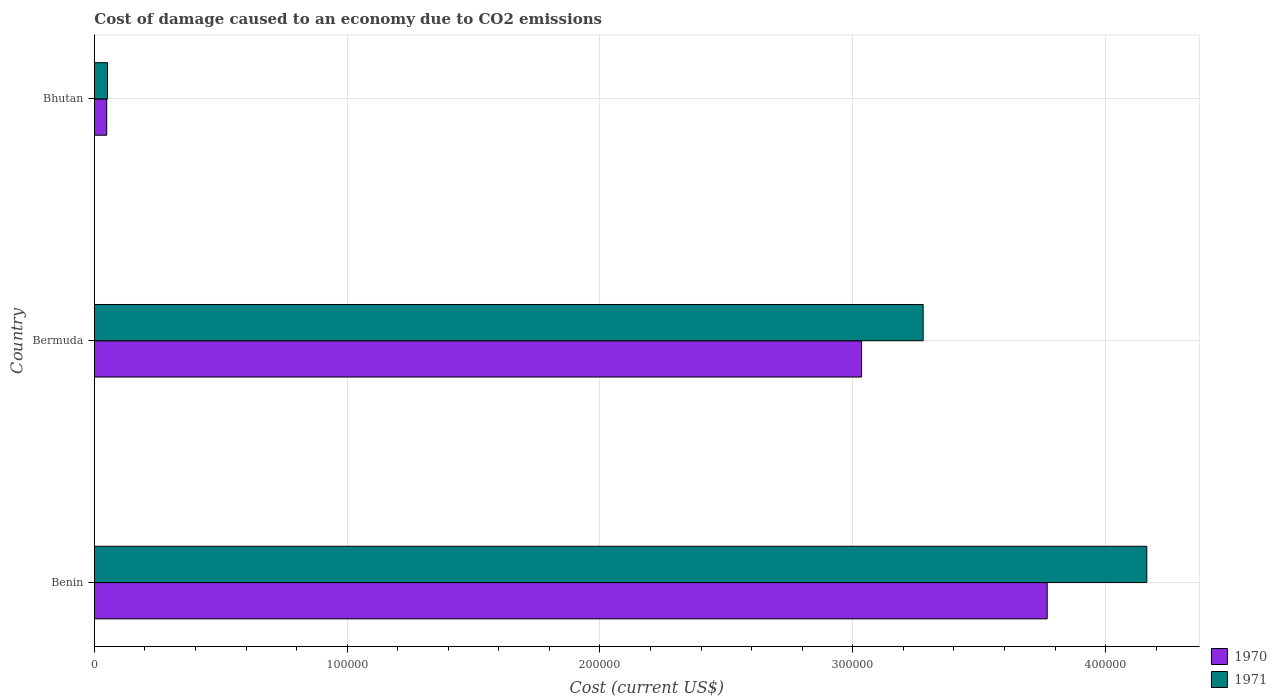How many different coloured bars are there?
Keep it short and to the point. 2. Are the number of bars per tick equal to the number of legend labels?
Provide a succinct answer. Yes. How many bars are there on the 2nd tick from the top?
Your answer should be compact. 2. What is the label of the 2nd group of bars from the top?
Provide a short and direct response. Bermuda. In how many cases, is the number of bars for a given country not equal to the number of legend labels?
Provide a succinct answer. 0. What is the cost of damage caused due to CO2 emissisons in 1971 in Benin?
Your answer should be very brief. 4.16e+05. Across all countries, what is the maximum cost of damage caused due to CO2 emissisons in 1971?
Ensure brevity in your answer.  4.16e+05. Across all countries, what is the minimum cost of damage caused due to CO2 emissisons in 1970?
Provide a short and direct response. 4894.68. In which country was the cost of damage caused due to CO2 emissisons in 1970 maximum?
Offer a terse response. Benin. In which country was the cost of damage caused due to CO2 emissisons in 1970 minimum?
Offer a very short reply. Bhutan. What is the total cost of damage caused due to CO2 emissisons in 1971 in the graph?
Offer a very short reply. 7.49e+05. What is the difference between the cost of damage caused due to CO2 emissisons in 1970 in Benin and that in Bhutan?
Ensure brevity in your answer.  3.72e+05. What is the difference between the cost of damage caused due to CO2 emissisons in 1971 in Bhutan and the cost of damage caused due to CO2 emissisons in 1970 in Benin?
Your answer should be very brief. -3.72e+05. What is the average cost of damage caused due to CO2 emissisons in 1971 per country?
Your answer should be very brief. 2.50e+05. What is the difference between the cost of damage caused due to CO2 emissisons in 1971 and cost of damage caused due to CO2 emissisons in 1970 in Bhutan?
Your answer should be very brief. 308.99. What is the ratio of the cost of damage caused due to CO2 emissisons in 1970 in Bermuda to that in Bhutan?
Make the answer very short. 62. Is the cost of damage caused due to CO2 emissisons in 1971 in Bermuda less than that in Bhutan?
Your answer should be compact. No. Is the difference between the cost of damage caused due to CO2 emissisons in 1971 in Benin and Bermuda greater than the difference between the cost of damage caused due to CO2 emissisons in 1970 in Benin and Bermuda?
Your response must be concise. Yes. What is the difference between the highest and the second highest cost of damage caused due to CO2 emissisons in 1971?
Ensure brevity in your answer.  8.85e+04. What is the difference between the highest and the lowest cost of damage caused due to CO2 emissisons in 1970?
Give a very brief answer. 3.72e+05. What does the 1st bar from the top in Benin represents?
Offer a terse response. 1971. How many bars are there?
Offer a terse response. 6. Are all the bars in the graph horizontal?
Make the answer very short. Yes. Does the graph contain grids?
Make the answer very short. Yes. Where does the legend appear in the graph?
Your response must be concise. Bottom right. How many legend labels are there?
Keep it short and to the point. 2. What is the title of the graph?
Ensure brevity in your answer.  Cost of damage caused to an economy due to CO2 emissions. What is the label or title of the X-axis?
Your answer should be very brief. Cost (current US$). What is the Cost (current US$) in 1970 in Benin?
Your answer should be very brief. 3.77e+05. What is the Cost (current US$) in 1971 in Benin?
Make the answer very short. 4.16e+05. What is the Cost (current US$) in 1970 in Bermuda?
Make the answer very short. 3.03e+05. What is the Cost (current US$) of 1971 in Bermuda?
Keep it short and to the point. 3.28e+05. What is the Cost (current US$) in 1970 in Bhutan?
Give a very brief answer. 4894.68. What is the Cost (current US$) in 1971 in Bhutan?
Make the answer very short. 5203.67. Across all countries, what is the maximum Cost (current US$) in 1970?
Keep it short and to the point. 3.77e+05. Across all countries, what is the maximum Cost (current US$) of 1971?
Keep it short and to the point. 4.16e+05. Across all countries, what is the minimum Cost (current US$) of 1970?
Keep it short and to the point. 4894.68. Across all countries, what is the minimum Cost (current US$) in 1971?
Your response must be concise. 5203.67. What is the total Cost (current US$) in 1970 in the graph?
Provide a succinct answer. 6.85e+05. What is the total Cost (current US$) of 1971 in the graph?
Offer a very short reply. 7.49e+05. What is the difference between the Cost (current US$) in 1970 in Benin and that in Bermuda?
Provide a succinct answer. 7.34e+04. What is the difference between the Cost (current US$) in 1971 in Benin and that in Bermuda?
Keep it short and to the point. 8.85e+04. What is the difference between the Cost (current US$) in 1970 in Benin and that in Bhutan?
Ensure brevity in your answer.  3.72e+05. What is the difference between the Cost (current US$) of 1971 in Benin and that in Bhutan?
Give a very brief answer. 4.11e+05. What is the difference between the Cost (current US$) of 1970 in Bermuda and that in Bhutan?
Your answer should be compact. 2.99e+05. What is the difference between the Cost (current US$) in 1971 in Bermuda and that in Bhutan?
Make the answer very short. 3.23e+05. What is the difference between the Cost (current US$) of 1970 in Benin and the Cost (current US$) of 1971 in Bermuda?
Ensure brevity in your answer.  4.91e+04. What is the difference between the Cost (current US$) of 1970 in Benin and the Cost (current US$) of 1971 in Bhutan?
Provide a short and direct response. 3.72e+05. What is the difference between the Cost (current US$) in 1970 in Bermuda and the Cost (current US$) in 1971 in Bhutan?
Ensure brevity in your answer.  2.98e+05. What is the average Cost (current US$) of 1970 per country?
Give a very brief answer. 2.28e+05. What is the average Cost (current US$) in 1971 per country?
Your answer should be compact. 2.50e+05. What is the difference between the Cost (current US$) in 1970 and Cost (current US$) in 1971 in Benin?
Offer a terse response. -3.94e+04. What is the difference between the Cost (current US$) in 1970 and Cost (current US$) in 1971 in Bermuda?
Keep it short and to the point. -2.44e+04. What is the difference between the Cost (current US$) in 1970 and Cost (current US$) in 1971 in Bhutan?
Keep it short and to the point. -308.99. What is the ratio of the Cost (current US$) in 1970 in Benin to that in Bermuda?
Offer a very short reply. 1.24. What is the ratio of the Cost (current US$) of 1971 in Benin to that in Bermuda?
Give a very brief answer. 1.27. What is the ratio of the Cost (current US$) in 1971 in Benin to that in Bhutan?
Provide a short and direct response. 80. What is the ratio of the Cost (current US$) of 1971 in Bermuda to that in Bhutan?
Your answer should be compact. 63. What is the difference between the highest and the second highest Cost (current US$) in 1970?
Ensure brevity in your answer.  7.34e+04. What is the difference between the highest and the second highest Cost (current US$) in 1971?
Give a very brief answer. 8.85e+04. What is the difference between the highest and the lowest Cost (current US$) in 1970?
Ensure brevity in your answer.  3.72e+05. What is the difference between the highest and the lowest Cost (current US$) of 1971?
Offer a very short reply. 4.11e+05. 